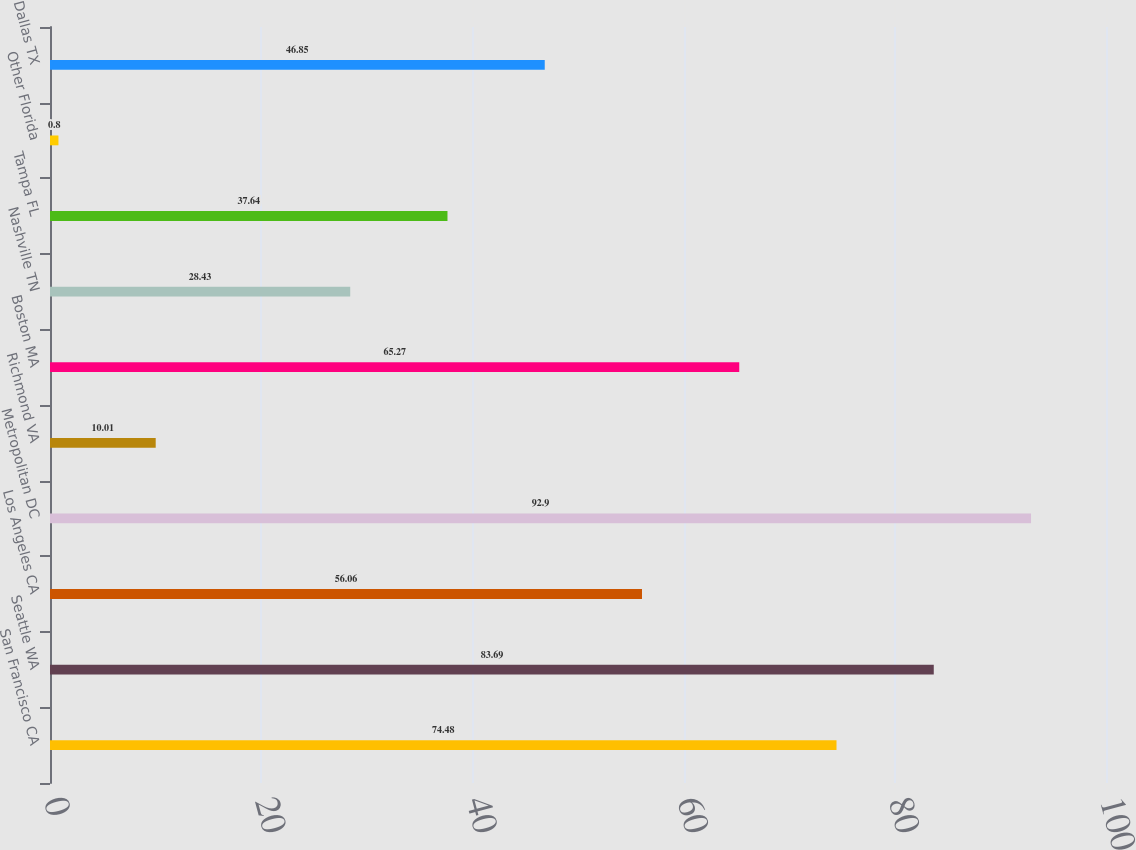Convert chart. <chart><loc_0><loc_0><loc_500><loc_500><bar_chart><fcel>San Francisco CA<fcel>Seattle WA<fcel>Los Angeles CA<fcel>Metropolitan DC<fcel>Richmond VA<fcel>Boston MA<fcel>Nashville TN<fcel>Tampa FL<fcel>Other Florida<fcel>Dallas TX<nl><fcel>74.48<fcel>83.69<fcel>56.06<fcel>92.9<fcel>10.01<fcel>65.27<fcel>28.43<fcel>37.64<fcel>0.8<fcel>46.85<nl></chart> 